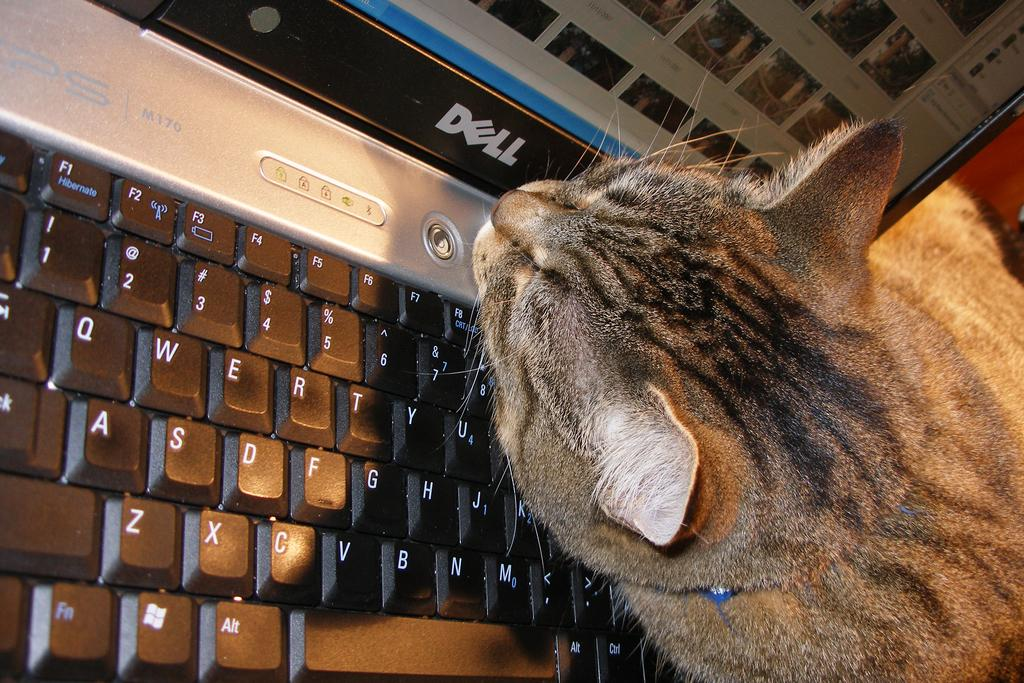What electronic device is present in the picture? There is a laptop in the picture. What type of animal can be seen in the picture? There is a cat in the picture. Can you describe the appearance of the cat? The cat is black and grey in color. How does the cat cause a bath in the picture? There is no bath present in the image, and the cat does not cause a bath in the picture. 